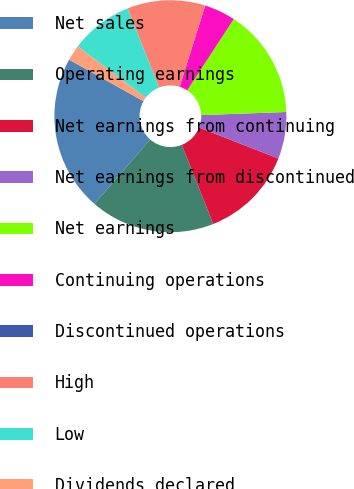Convert chart to OTSL. <chart><loc_0><loc_0><loc_500><loc_500><pie_chart><fcel>Net sales<fcel>Operating earnings<fcel>Net earnings from continuing<fcel>Net earnings from discontinued<fcel>Net earnings<fcel>Continuing operations<fcel>Discontinued operations<fcel>High<fcel>Low<fcel>Dividends declared<nl><fcel>21.74%<fcel>17.39%<fcel>13.04%<fcel>6.52%<fcel>15.22%<fcel>4.35%<fcel>0.0%<fcel>10.87%<fcel>8.7%<fcel>2.17%<nl></chart> 